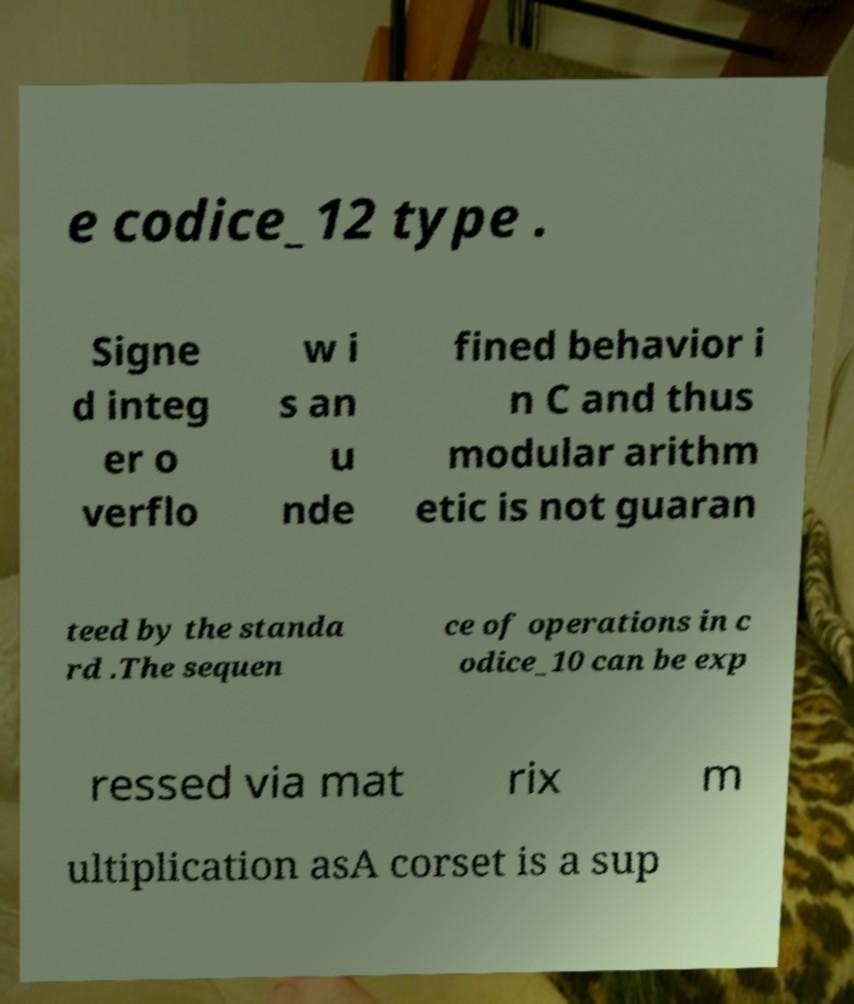Could you extract and type out the text from this image? e codice_12 type . Signe d integ er o verflo w i s an u nde fined behavior i n C and thus modular arithm etic is not guaran teed by the standa rd .The sequen ce of operations in c odice_10 can be exp ressed via mat rix m ultiplication asA corset is a sup 